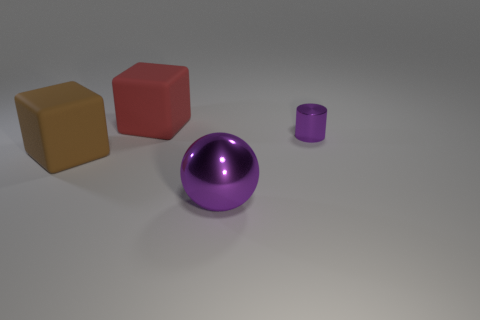How many things are brown blocks or large cubes in front of the tiny purple cylinder?
Provide a short and direct response. 1. What number of things are either metal objects in front of the large brown cube or shiny things that are to the left of the small shiny object?
Your answer should be very brief. 1. Are there any big matte things in front of the large red thing?
Give a very brief answer. Yes. What color is the large matte thing behind the big rubber object that is left of the big matte object behind the big brown thing?
Provide a short and direct response. Red. Does the large purple shiny thing have the same shape as the red matte object?
Offer a very short reply. No. The other block that is made of the same material as the big red block is what color?
Ensure brevity in your answer.  Brown. What number of objects are things that are right of the large brown block or brown objects?
Offer a terse response. 4. What size is the red matte cube behind the brown cube?
Offer a terse response. Large. There is a brown block; is it the same size as the rubber object that is behind the brown rubber thing?
Make the answer very short. Yes. What color is the rubber thing on the left side of the big red cube on the left side of the big sphere?
Your answer should be very brief. Brown. 